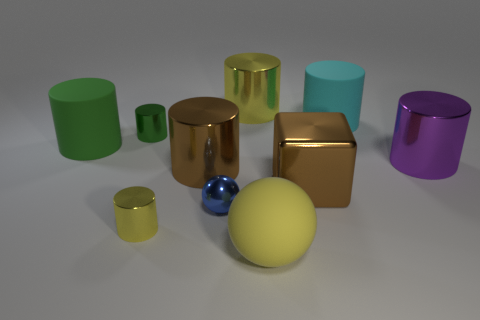Subtract all purple cylinders. How many cylinders are left? 6 Subtract all tiny green metallic cylinders. How many cylinders are left? 6 Subtract 2 cylinders. How many cylinders are left? 5 Subtract all red cylinders. Subtract all green balls. How many cylinders are left? 7 Subtract all cylinders. How many objects are left? 3 Add 5 red shiny objects. How many red shiny objects exist? 5 Subtract 0 yellow cubes. How many objects are left? 10 Subtract all large yellow rubber things. Subtract all large metal objects. How many objects are left? 5 Add 6 small objects. How many small objects are left? 9 